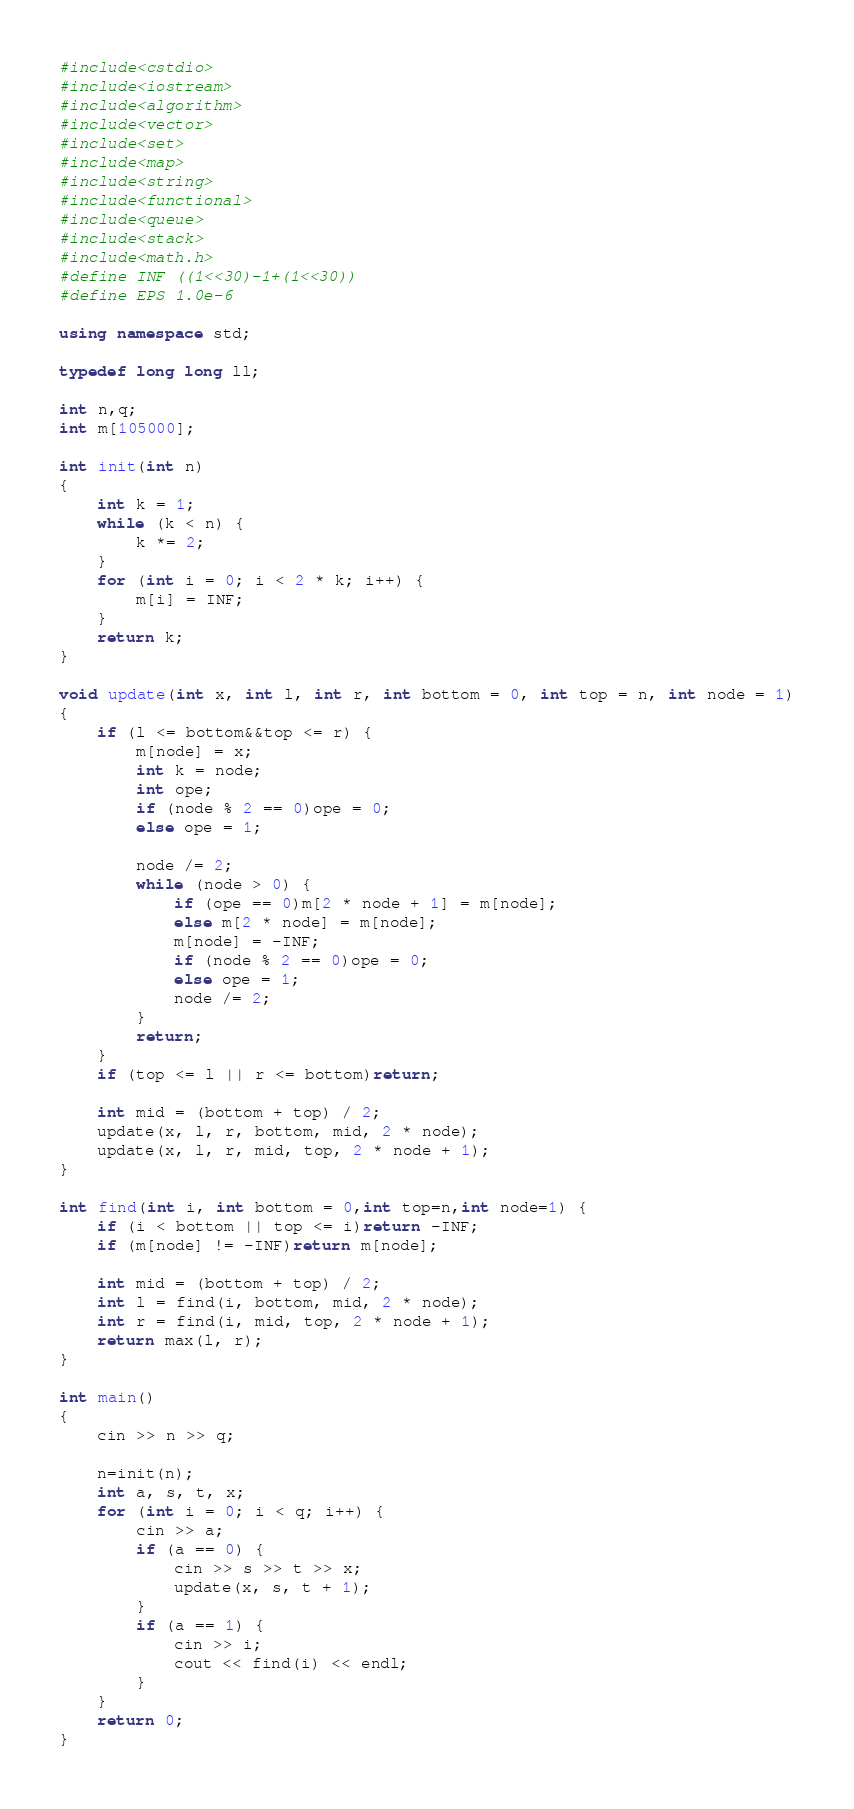Convert code to text. <code><loc_0><loc_0><loc_500><loc_500><_C++_>#include<cstdio>
#include<iostream>
#include<algorithm>
#include<vector>
#include<set>
#include<map>
#include<string>
#include<functional>
#include<queue>
#include<stack>
#include<math.h>
#define INF ((1<<30)-1+(1<<30))
#define EPS 1.0e-6

using namespace std;

typedef long long ll;

int n,q;
int m[105000];

int init(int n)
{
	int k = 1;
	while (k < n) {
		k *= 2;
	}
	for (int i = 0; i < 2 * k; i++) {
		m[i] = INF;
	}
	return k;
}

void update(int x, int l, int r, int bottom = 0, int top = n, int node = 1)
{
	if (l <= bottom&&top <= r) {
		m[node] = x;
		int k = node;
		int ope;
		if (node % 2 == 0)ope = 0;
		else ope = 1;

		node /= 2;
		while (node > 0) {
			if (ope == 0)m[2 * node + 1] = m[node];
			else m[2 * node] = m[node];
			m[node] = -INF;
			if (node % 2 == 0)ope = 0;
			else ope = 1;
			node /= 2;
		}
		return;
	}
	if (top <= l || r <= bottom)return;

	int mid = (bottom + top) / 2;
	update(x, l, r, bottom, mid, 2 * node);
	update(x, l, r, mid, top, 2 * node + 1);
}

int find(int i, int bottom = 0,int top=n,int node=1) {
	if (i < bottom || top <= i)return -INF;
	if (m[node] != -INF)return m[node];
	
	int mid = (bottom + top) / 2;
	int l = find(i, bottom, mid, 2 * node);
	int r = find(i, mid, top, 2 * node + 1);
	return max(l, r);
}

int main()
{
	cin >> n >> q;

	n=init(n);
	int a, s, t, x;
	for (int i = 0; i < q; i++) {
		cin >> a;
		if (a == 0) {
			cin >> s >> t >> x;
			update(x, s, t + 1);
		}
		if (a == 1) {
			cin >> i;
			cout << find(i) << endl;
		}
	}
	return 0;
}</code> 